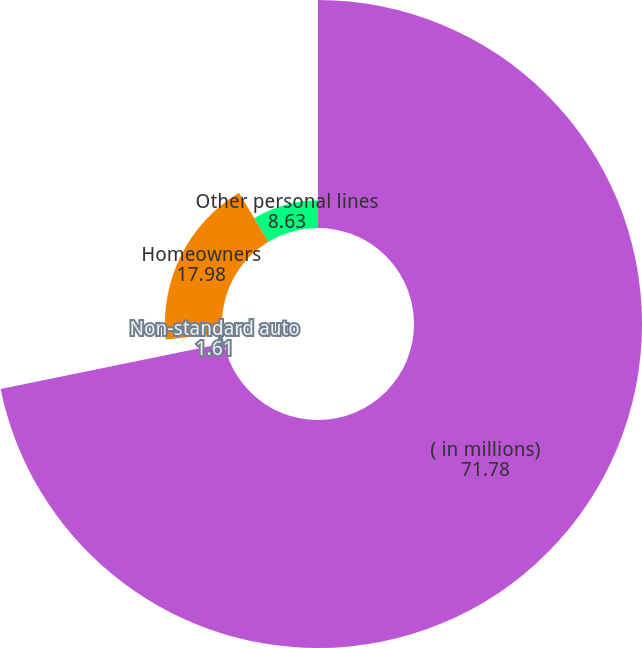Convert chart to OTSL. <chart><loc_0><loc_0><loc_500><loc_500><pie_chart><fcel>( in millions)<fcel>Non-standard auto<fcel>Homeowners<fcel>Other personal lines<nl><fcel>71.78%<fcel>1.61%<fcel>17.98%<fcel>8.63%<nl></chart> 